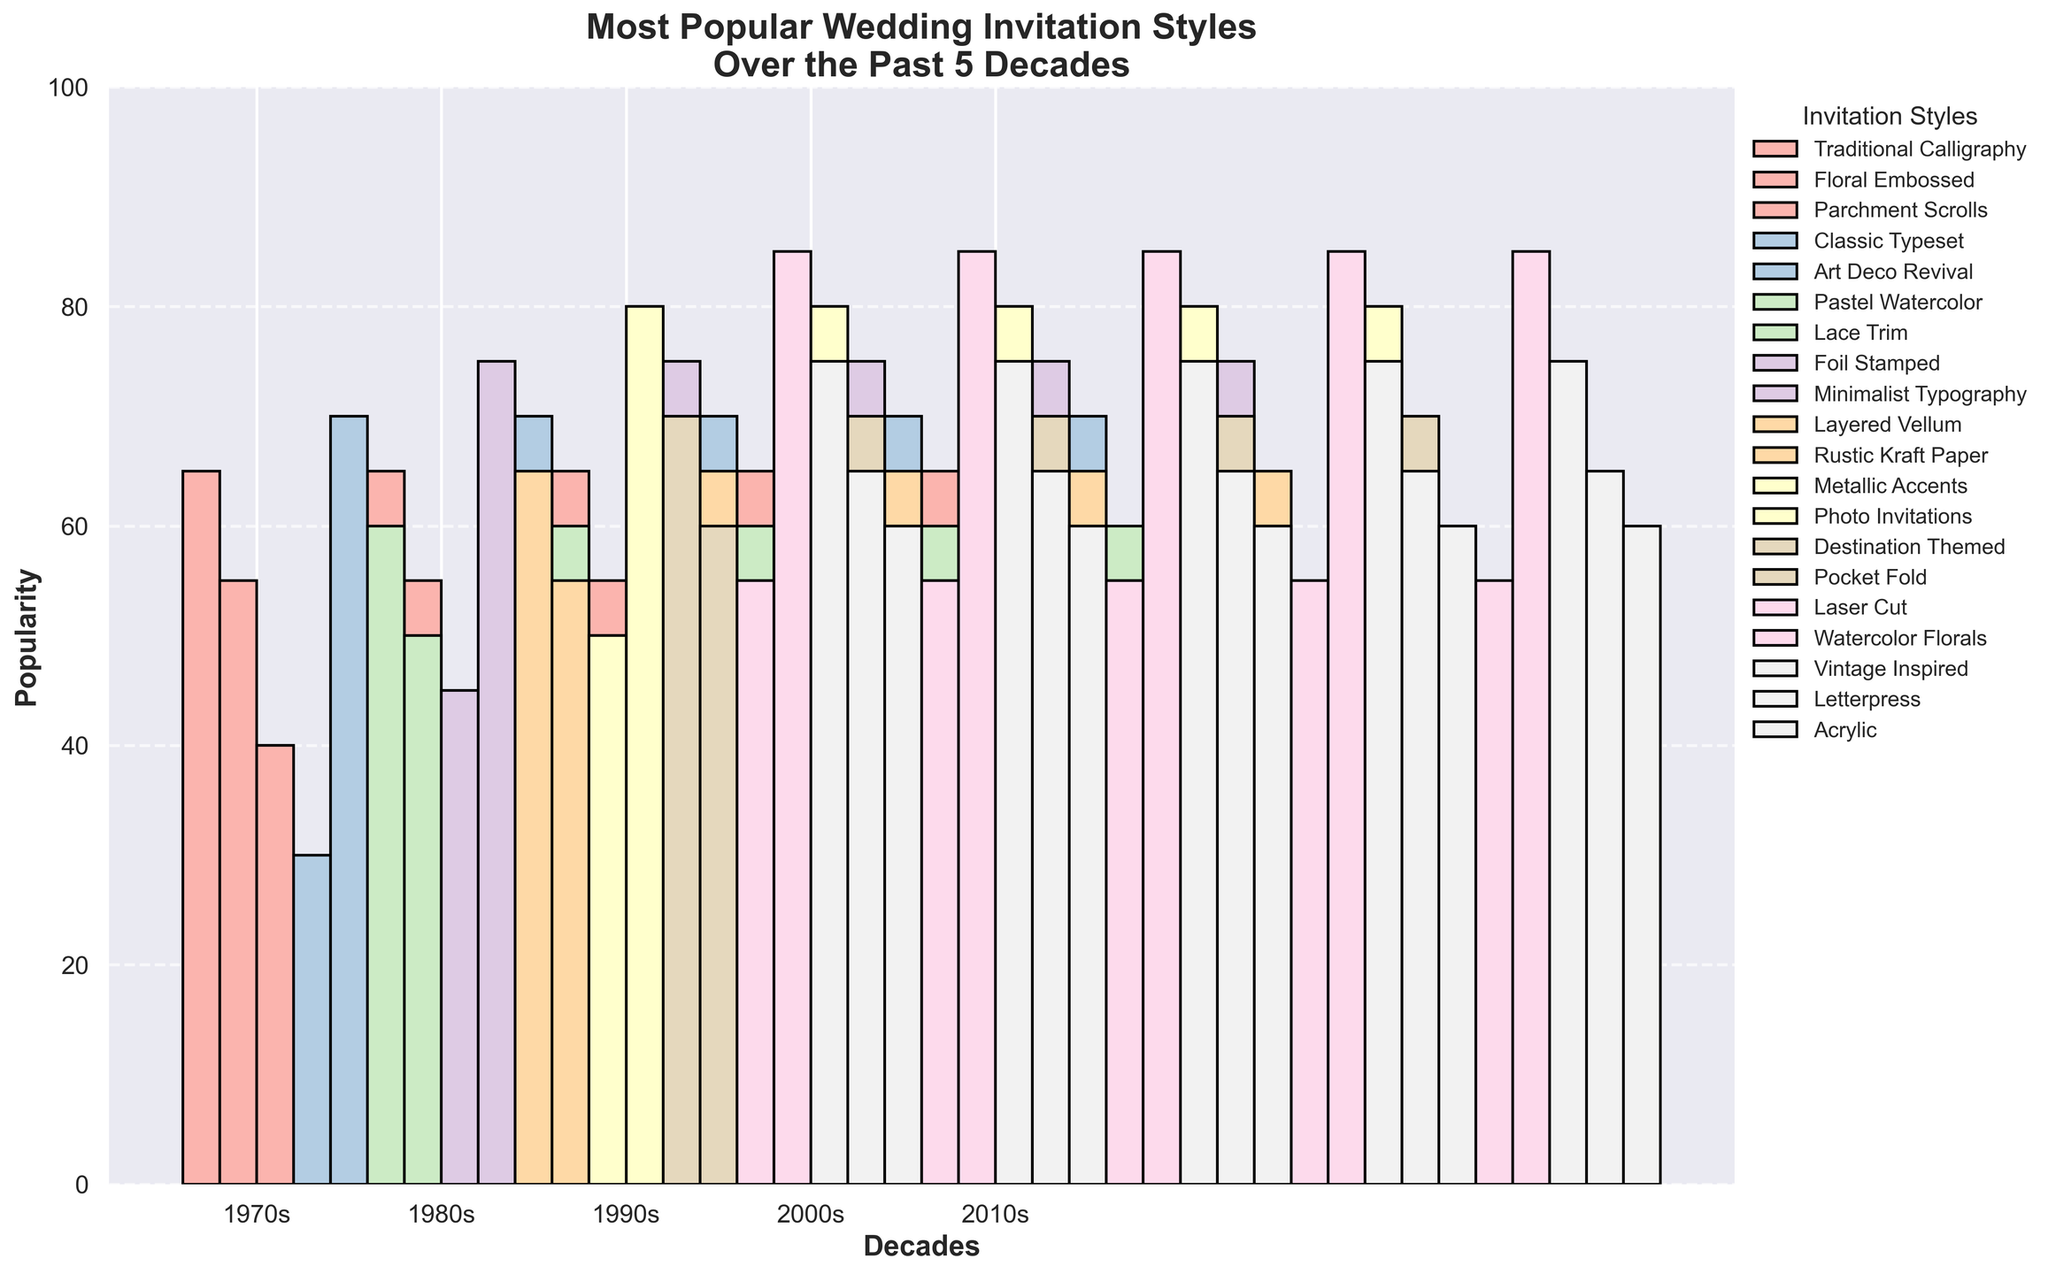Which decade had the highest popularity for Watercolor Florals style? To determine this, look for the bar representing Watercolor Florals and find the decade on the x-axis where this bar is highest. The highest bar for Watercolor Florals is in the 2010s.
Answer: 2010s Which style in the 1980s had the second highest popularity? First, identify all the bars for the 1980s. Then, look for the second tallest bar among them. The second highest bar is for Pastel Watercolor.
Answer: Pastel Watercolor Compare the popularity between Traditional Calligraphy in the 1970s and Vintage Inspired in the 2010s. Which one is more popular? Find the heights of the bars for Traditional Calligraphy in the 1970s and Vintage Inspired in the 2010s. Traditional Calligraphy has a height of 65, while Vintage Inspired has a height of 75. Therefore, Vintage Inspired is more popular.
Answer: Vintage Inspired Which style had exactly 50 popularity points in both the 1980s and 1990s? Identify the bars that have a height of 50 in the 1980s and 1990s. Lace Trim in the 1980s and Metallic Accents in the 1990s both have 50 popularity points, but neither appears in both decades. Therefore, no style matches the criteria.
Answer: None By how much did the popularity of Photo Invitations in the 2000s exceed Art Deco Revival in the 1980s? Determine the heights of the bars for Photo Invitations in the 2000s and Art Deco Revival in the 1980s. Photo Invitations have 80 popularity points, while Art Deco Revival has 70. The difference is 80 - 70 = 10.
Answer: 10 Which decade had the greatest variety of wedding invitation styles shown? Count the number of different styles for each decade based on the bars. Each decade (1970s, 1980s, 1990s, 2000s, 2010s) has 4 styles each, so all have the same variety.
Answer: Equal variety In the 2010s, what is the difference in popularity between Letterpress and Acrylic styles? Identify the heights of the bars for Letterpress and Acrylic in the 2010s. Letterpress has 65 popularity points, and Acrylic has 60. The difference is 65 - 60 = 5.
Answer: 5 Which style in the 1990s had the highest popularity? Look at the bars for the 1990s and find the tallest one. The highest bar in the 1990s is for Minimalist Typography.
Answer: Minimalist Typography 